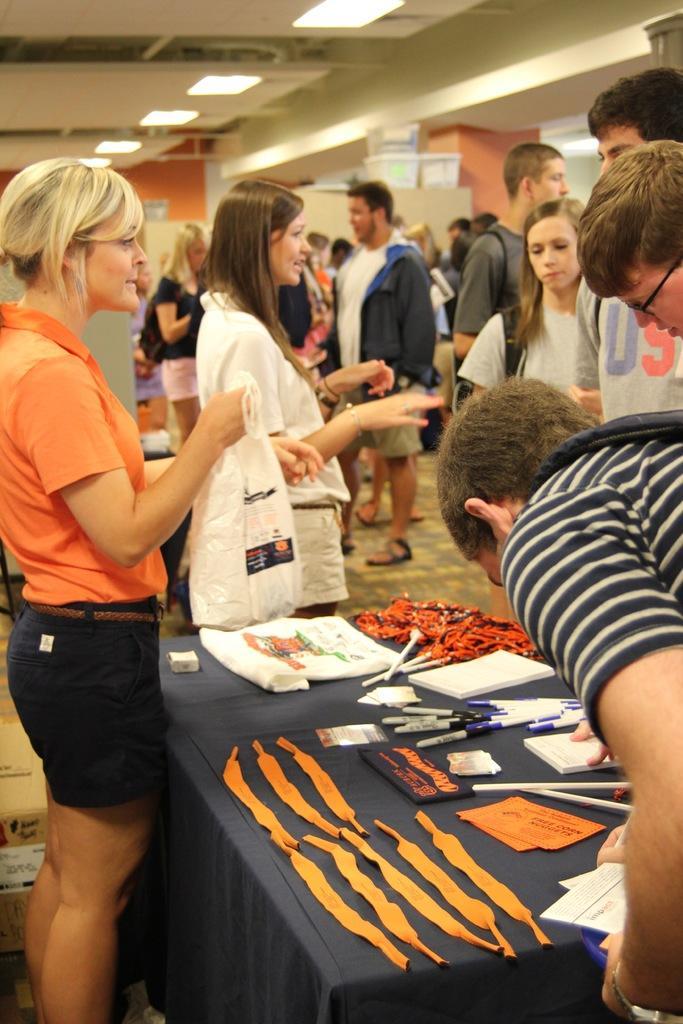Please provide a concise description of this image. Here we can see some persons are standing on the floor. This is table. On the table there are pens and books. These are the lights. And there is a pillar and this is floor. 